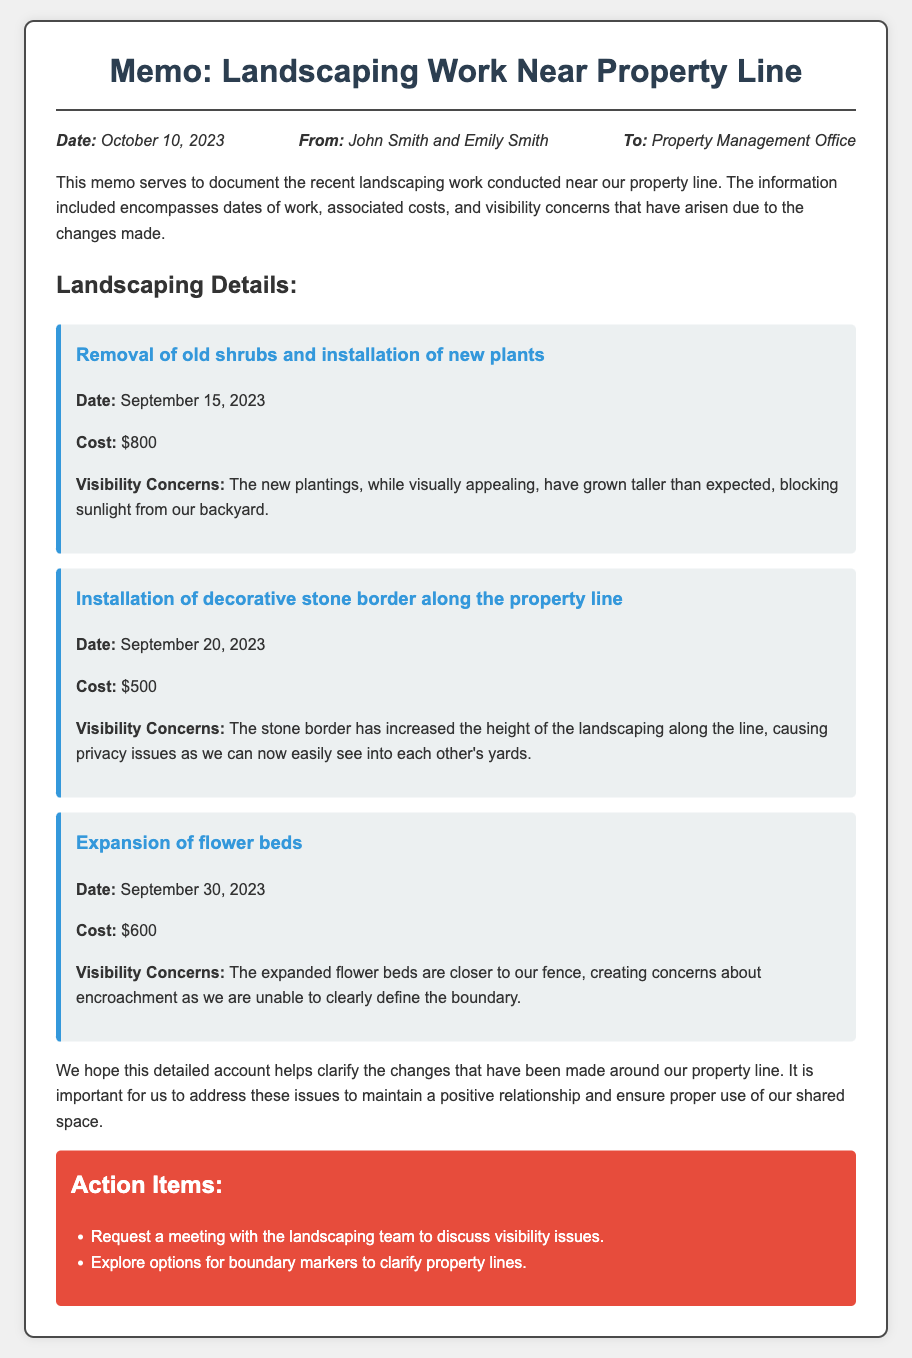What is the date of the memo? The date of the memo is stated in the meta section of the document.
Answer: October 10, 2023 Who are the authors of the memo? The authors are listed in the meta section, under 'From.'
Answer: John Smith and Emily Smith What was the cost of removing old shrubs? The cost is indicated in the landscaping details section for that specific task.
Answer: $800 When was the decorative stone border installed? The installation date is mentioned in the landscaping details.
Answer: September 20, 2023 What visibility concern arose from the expanded flower beds? The document mentions visibility concerns related to the flower beds under its specific section.
Answer: Encroachment What total cost was incurred for all landscaping work? The total cost can be calculated by adding all listed costs: $800 + $500 + $600.
Answer: $1900 What action item involves boundary markers? The action items entail exploring options for boundary markers.
Answer: Explore options for boundary markers Which landscaping work created privacy issues? The document details various jobs and identifies the one that caused privacy concerns.
Answer: Installation of decorative stone border 